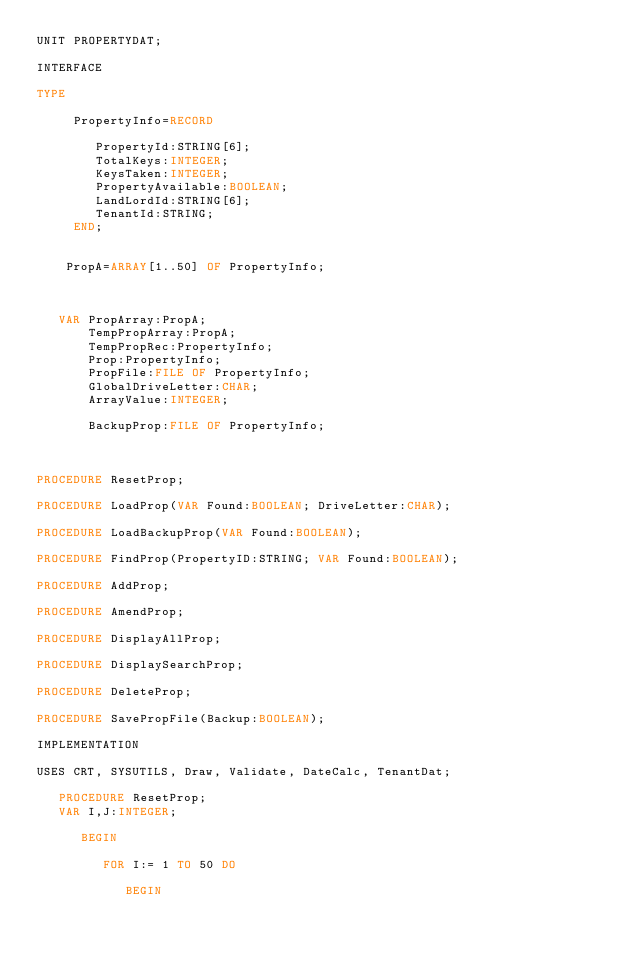Convert code to text. <code><loc_0><loc_0><loc_500><loc_500><_Pascal_>UNIT PROPERTYDAT;

INTERFACE

TYPE

     PropertyInfo=RECORD

        PropertyId:STRING[6];
        TotalKeys:INTEGER;
        KeysTaken:INTEGER;
        PropertyAvailable:BOOLEAN;
        LandLordId:STRING[6];
        TenantId:STRING;
     END;


    PropA=ARRAY[1..50] OF PropertyInfo;



   VAR PropArray:PropA;
       TempPropArray:PropA;
       TempPropRec:PropertyInfo;
       Prop:PropertyInfo;
       PropFile:FILE OF PropertyInfo;
       GlobalDriveLetter:CHAR;
       ArrayValue:INTEGER;

       BackupProp:FILE OF PropertyInfo;



PROCEDURE ResetProp;

PROCEDURE LoadProp(VAR Found:BOOLEAN; DriveLetter:CHAR);

PROCEDURE LoadBackupProp(VAR Found:BOOLEAN);

PROCEDURE FindProp(PropertyID:STRING; VAR Found:BOOLEAN);

PROCEDURE AddProp;

PROCEDURE AmendProp;

PROCEDURE DisplayAllProp;

PROCEDURE DisplaySearchProp;

PROCEDURE DeleteProp;

PROCEDURE SavePropFile(Backup:BOOLEAN);

IMPLEMENTATION

USES CRT, SYSUTILS, Draw, Validate, DateCalc, TenantDat;

   PROCEDURE ResetProp;
   VAR I,J:INTEGER;

      BEGIN

         FOR I:= 1 TO 50 DO

            BEGIN</code> 